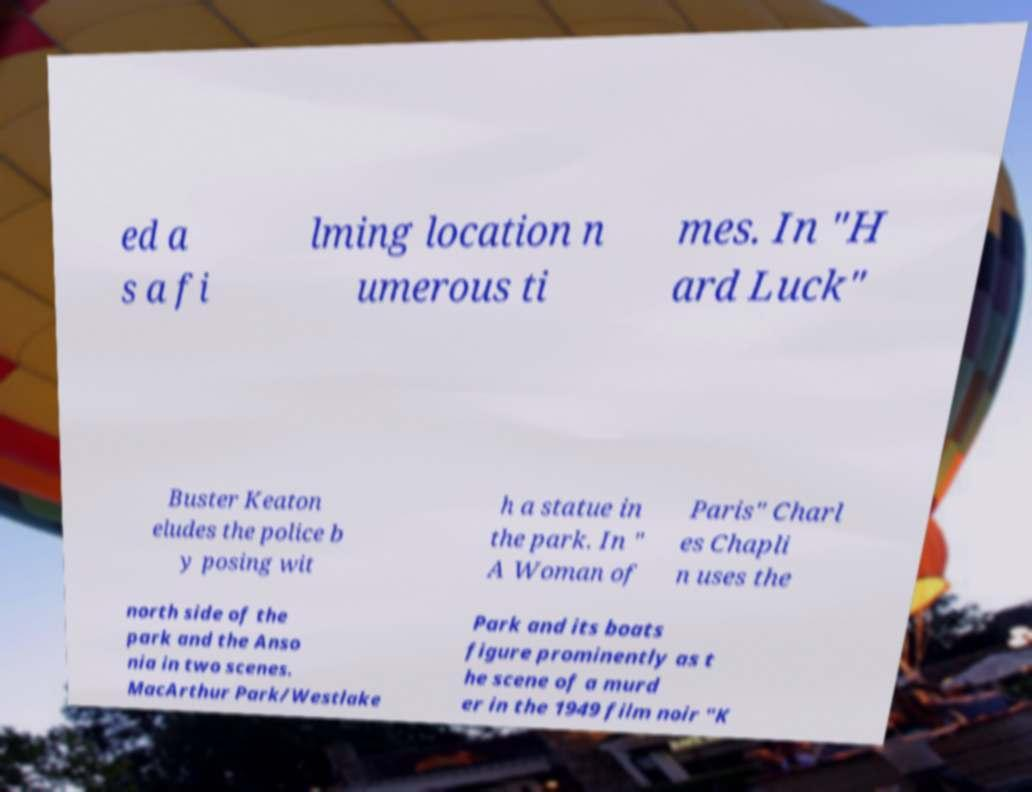What messages or text are displayed in this image? I need them in a readable, typed format. ed a s a fi lming location n umerous ti mes. In "H ard Luck" Buster Keaton eludes the police b y posing wit h a statue in the park. In " A Woman of Paris" Charl es Chapli n uses the north side of the park and the Anso nia in two scenes. MacArthur Park/Westlake Park and its boats figure prominently as t he scene of a murd er in the 1949 film noir "K 